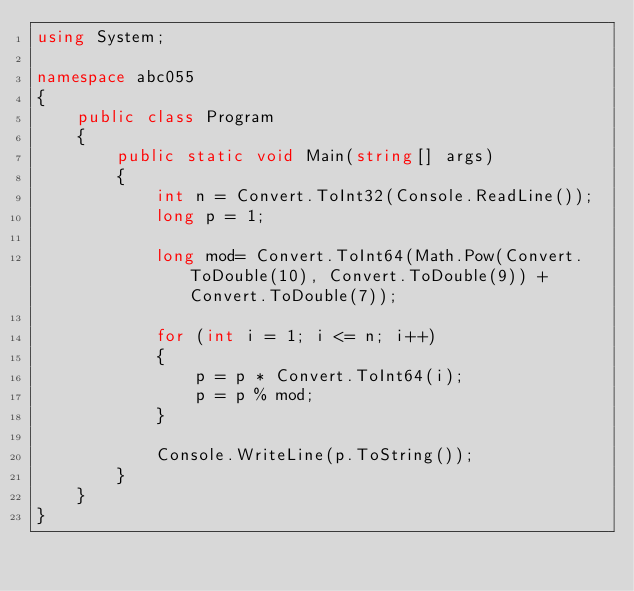<code> <loc_0><loc_0><loc_500><loc_500><_C#_>using System;

namespace abc055
{
    public class Program
    {
        public static void Main(string[] args)
        {
            int n = Convert.ToInt32(Console.ReadLine());
            long p = 1;

            long mod= Convert.ToInt64(Math.Pow(Convert.ToDouble(10), Convert.ToDouble(9)) + Convert.ToDouble(7));
            
            for (int i = 1; i <= n; i++)
            {
                p = p * Convert.ToInt64(i);
                p = p % mod;               
            }

            Console.WriteLine(p.ToString());
        }
    }
}
</code> 